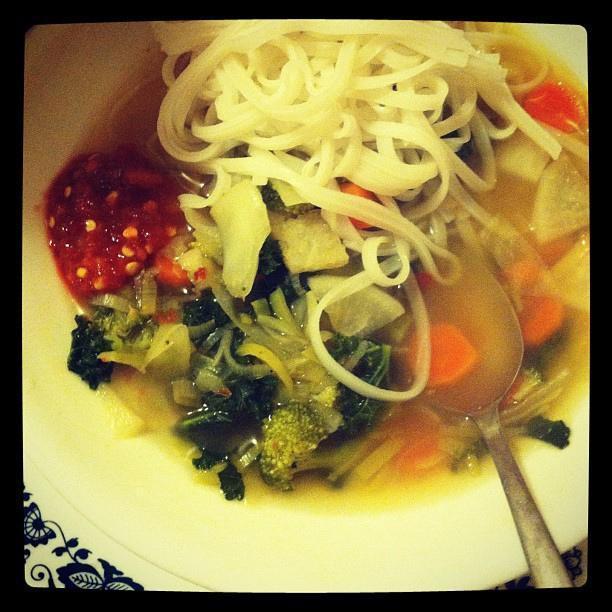How many carrots can you see?
Give a very brief answer. 2. How many broccolis can you see?
Give a very brief answer. 2. How many people are wearing blue shirts?
Give a very brief answer. 0. 